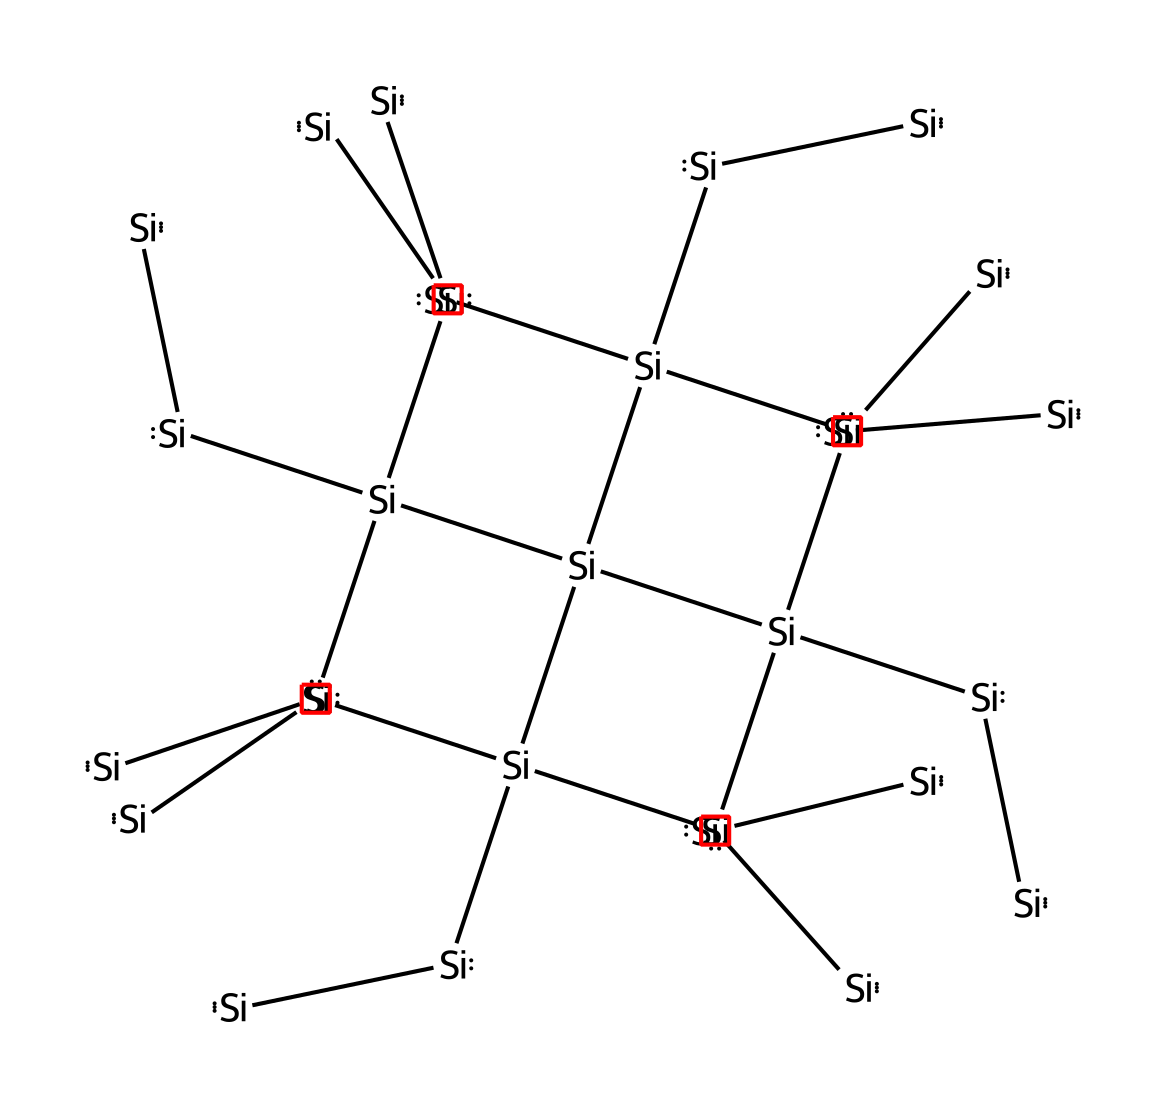What is the primary element in this structure? This structure is based on silicon, which is the main component represented in the SMILES by the repetitive '[Si]' notation.
Answer: silicon How many silicon atoms are in the crystal lattice? The structure shows a repetitive complexity with 8 silicon atoms represented in the SMILES format by counting each '[Si]' segment.
Answer: eight What type of solid is represented by this chemical? This chemical represents a crystalline solid, specifically silicon, which has a well-defined geometric crystal lattice structure.
Answer: crystalline solid What characteristic of silicon allows it to be used in computer chips? The tetrahedral arrangement of silicon atoms allows for efficient conduction of electricity due to its semiconductor properties and ability to form complex conductive paths.
Answer: semiconductor What arrangement do the silicon atoms form in the crystal lattice? The silicon atoms form a diamond cubic lattice arrangement, which is a repeating structure that provides stability and conductivity beneficial for electronic applications.
Answer: diamond cubic Which property of the silicon crystal lattice aids in its use in electronics? The regular arrangement of silicon atoms leads to predictability in electronic properties, including band gap manipulation, essential for semiconductor applications.
Answer: predictability How does the lattice arrangement affect the conductivity of silicon? The lattice arrangement allows for the formation of energy bands, which control the flow of electrons, making silicon a suitable material for conductivity in electronic devices.
Answer: energy bands 